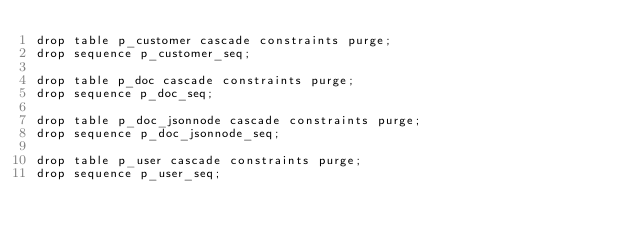<code> <loc_0><loc_0><loc_500><loc_500><_SQL_>drop table p_customer cascade constraints purge;
drop sequence p_customer_seq;

drop table p_doc cascade constraints purge;
drop sequence p_doc_seq;

drop table p_doc_jsonnode cascade constraints purge;
drop sequence p_doc_jsonnode_seq;

drop table p_user cascade constraints purge;
drop sequence p_user_seq;

</code> 